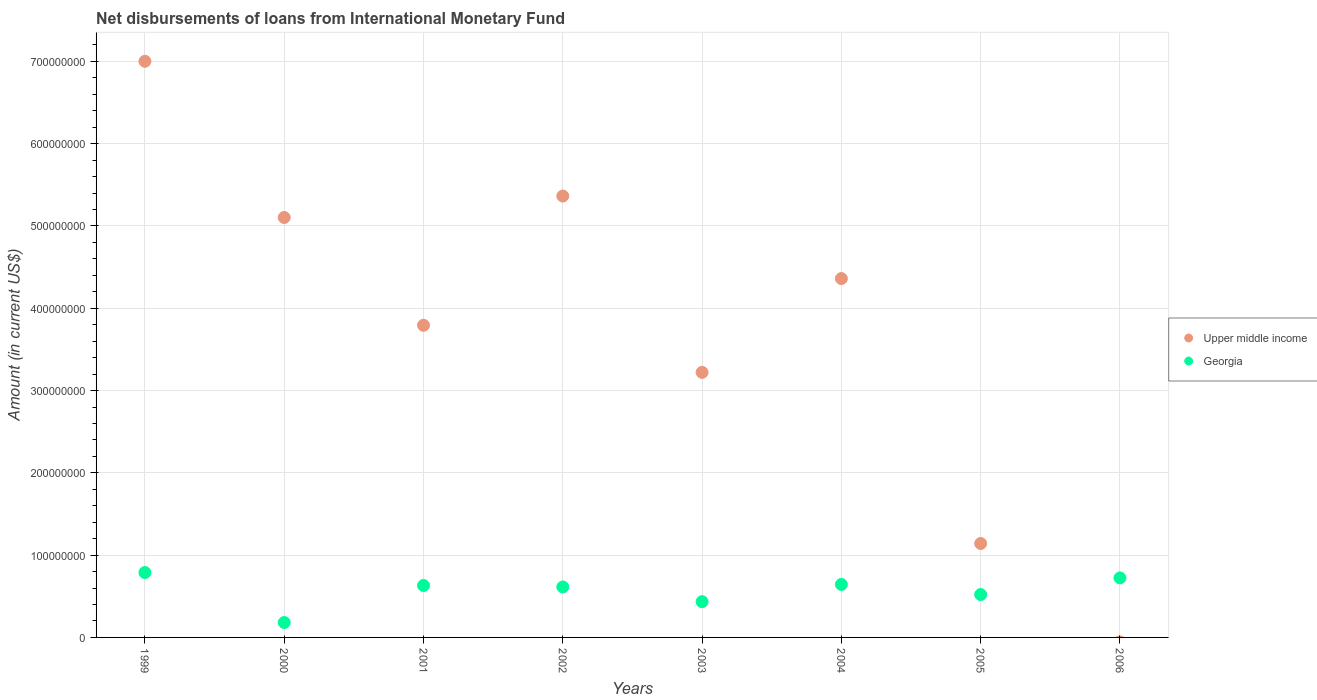Is the number of dotlines equal to the number of legend labels?
Offer a very short reply. No. What is the amount of loans disbursed in Upper middle income in 2005?
Make the answer very short. 1.14e+08. Across all years, what is the maximum amount of loans disbursed in Georgia?
Your answer should be compact. 7.88e+07. Across all years, what is the minimum amount of loans disbursed in Georgia?
Ensure brevity in your answer.  1.81e+07. What is the total amount of loans disbursed in Upper middle income in the graph?
Provide a succinct answer. 3.00e+09. What is the difference between the amount of loans disbursed in Georgia in 2001 and that in 2006?
Your answer should be compact. -9.24e+06. What is the difference between the amount of loans disbursed in Georgia in 2002 and the amount of loans disbursed in Upper middle income in 1999?
Make the answer very short. -6.39e+08. What is the average amount of loans disbursed in Upper middle income per year?
Provide a succinct answer. 3.75e+08. In the year 1999, what is the difference between the amount of loans disbursed in Upper middle income and amount of loans disbursed in Georgia?
Offer a terse response. 6.21e+08. In how many years, is the amount of loans disbursed in Upper middle income greater than 600000000 US$?
Provide a succinct answer. 1. What is the ratio of the amount of loans disbursed in Georgia in 1999 to that in 2003?
Your response must be concise. 1.81. Is the amount of loans disbursed in Upper middle income in 2000 less than that in 2004?
Provide a succinct answer. No. Is the difference between the amount of loans disbursed in Upper middle income in 1999 and 2002 greater than the difference between the amount of loans disbursed in Georgia in 1999 and 2002?
Keep it short and to the point. Yes. What is the difference between the highest and the second highest amount of loans disbursed in Georgia?
Your answer should be very brief. 6.50e+06. What is the difference between the highest and the lowest amount of loans disbursed in Upper middle income?
Offer a terse response. 7.00e+08. Does the amount of loans disbursed in Upper middle income monotonically increase over the years?
Provide a short and direct response. No. How many years are there in the graph?
Your response must be concise. 8. What is the difference between two consecutive major ticks on the Y-axis?
Provide a short and direct response. 1.00e+08. Are the values on the major ticks of Y-axis written in scientific E-notation?
Make the answer very short. No. Does the graph contain grids?
Offer a very short reply. Yes. Where does the legend appear in the graph?
Offer a terse response. Center right. How many legend labels are there?
Your response must be concise. 2. What is the title of the graph?
Provide a short and direct response. Net disbursements of loans from International Monetary Fund. What is the Amount (in current US$) of Upper middle income in 1999?
Offer a terse response. 7.00e+08. What is the Amount (in current US$) of Georgia in 1999?
Your response must be concise. 7.88e+07. What is the Amount (in current US$) of Upper middle income in 2000?
Provide a succinct answer. 5.10e+08. What is the Amount (in current US$) of Georgia in 2000?
Offer a terse response. 1.81e+07. What is the Amount (in current US$) in Upper middle income in 2001?
Provide a short and direct response. 3.79e+08. What is the Amount (in current US$) in Georgia in 2001?
Provide a short and direct response. 6.31e+07. What is the Amount (in current US$) of Upper middle income in 2002?
Offer a very short reply. 5.36e+08. What is the Amount (in current US$) in Georgia in 2002?
Offer a very short reply. 6.13e+07. What is the Amount (in current US$) in Upper middle income in 2003?
Your response must be concise. 3.22e+08. What is the Amount (in current US$) of Georgia in 2003?
Make the answer very short. 4.35e+07. What is the Amount (in current US$) of Upper middle income in 2004?
Provide a succinct answer. 4.36e+08. What is the Amount (in current US$) in Georgia in 2004?
Keep it short and to the point. 6.44e+07. What is the Amount (in current US$) in Upper middle income in 2005?
Offer a very short reply. 1.14e+08. What is the Amount (in current US$) of Georgia in 2005?
Keep it short and to the point. 5.21e+07. What is the Amount (in current US$) of Upper middle income in 2006?
Your answer should be compact. 0. What is the Amount (in current US$) in Georgia in 2006?
Your answer should be very brief. 7.23e+07. Across all years, what is the maximum Amount (in current US$) in Upper middle income?
Your answer should be compact. 7.00e+08. Across all years, what is the maximum Amount (in current US$) in Georgia?
Provide a succinct answer. 7.88e+07. Across all years, what is the minimum Amount (in current US$) of Georgia?
Give a very brief answer. 1.81e+07. What is the total Amount (in current US$) in Upper middle income in the graph?
Keep it short and to the point. 3.00e+09. What is the total Amount (in current US$) in Georgia in the graph?
Ensure brevity in your answer.  4.54e+08. What is the difference between the Amount (in current US$) of Upper middle income in 1999 and that in 2000?
Your answer should be compact. 1.90e+08. What is the difference between the Amount (in current US$) in Georgia in 1999 and that in 2000?
Provide a short and direct response. 6.07e+07. What is the difference between the Amount (in current US$) of Upper middle income in 1999 and that in 2001?
Your answer should be very brief. 3.21e+08. What is the difference between the Amount (in current US$) in Georgia in 1999 and that in 2001?
Your answer should be compact. 1.57e+07. What is the difference between the Amount (in current US$) of Upper middle income in 1999 and that in 2002?
Your answer should be compact. 1.64e+08. What is the difference between the Amount (in current US$) of Georgia in 1999 and that in 2002?
Offer a terse response. 1.75e+07. What is the difference between the Amount (in current US$) in Upper middle income in 1999 and that in 2003?
Ensure brevity in your answer.  3.78e+08. What is the difference between the Amount (in current US$) in Georgia in 1999 and that in 2003?
Your answer should be very brief. 3.54e+07. What is the difference between the Amount (in current US$) of Upper middle income in 1999 and that in 2004?
Provide a short and direct response. 2.64e+08. What is the difference between the Amount (in current US$) in Georgia in 1999 and that in 2004?
Ensure brevity in your answer.  1.45e+07. What is the difference between the Amount (in current US$) in Upper middle income in 1999 and that in 2005?
Your answer should be compact. 5.86e+08. What is the difference between the Amount (in current US$) in Georgia in 1999 and that in 2005?
Provide a short and direct response. 2.67e+07. What is the difference between the Amount (in current US$) of Georgia in 1999 and that in 2006?
Keep it short and to the point. 6.50e+06. What is the difference between the Amount (in current US$) of Upper middle income in 2000 and that in 2001?
Provide a short and direct response. 1.31e+08. What is the difference between the Amount (in current US$) of Georgia in 2000 and that in 2001?
Your response must be concise. -4.50e+07. What is the difference between the Amount (in current US$) of Upper middle income in 2000 and that in 2002?
Offer a terse response. -2.61e+07. What is the difference between the Amount (in current US$) of Georgia in 2000 and that in 2002?
Your answer should be very brief. -4.32e+07. What is the difference between the Amount (in current US$) in Upper middle income in 2000 and that in 2003?
Ensure brevity in your answer.  1.88e+08. What is the difference between the Amount (in current US$) in Georgia in 2000 and that in 2003?
Your response must be concise. -2.54e+07. What is the difference between the Amount (in current US$) in Upper middle income in 2000 and that in 2004?
Give a very brief answer. 7.42e+07. What is the difference between the Amount (in current US$) in Georgia in 2000 and that in 2004?
Provide a succinct answer. -4.63e+07. What is the difference between the Amount (in current US$) in Upper middle income in 2000 and that in 2005?
Your answer should be compact. 3.96e+08. What is the difference between the Amount (in current US$) of Georgia in 2000 and that in 2005?
Offer a terse response. -3.40e+07. What is the difference between the Amount (in current US$) of Georgia in 2000 and that in 2006?
Your answer should be compact. -5.42e+07. What is the difference between the Amount (in current US$) of Upper middle income in 2001 and that in 2002?
Provide a succinct answer. -1.57e+08. What is the difference between the Amount (in current US$) in Georgia in 2001 and that in 2002?
Your answer should be compact. 1.78e+06. What is the difference between the Amount (in current US$) in Upper middle income in 2001 and that in 2003?
Provide a succinct answer. 5.72e+07. What is the difference between the Amount (in current US$) of Georgia in 2001 and that in 2003?
Offer a terse response. 1.96e+07. What is the difference between the Amount (in current US$) of Upper middle income in 2001 and that in 2004?
Ensure brevity in your answer.  -5.68e+07. What is the difference between the Amount (in current US$) of Georgia in 2001 and that in 2004?
Ensure brevity in your answer.  -1.27e+06. What is the difference between the Amount (in current US$) of Upper middle income in 2001 and that in 2005?
Provide a short and direct response. 2.65e+08. What is the difference between the Amount (in current US$) in Georgia in 2001 and that in 2005?
Give a very brief answer. 1.10e+07. What is the difference between the Amount (in current US$) in Georgia in 2001 and that in 2006?
Make the answer very short. -9.24e+06. What is the difference between the Amount (in current US$) of Upper middle income in 2002 and that in 2003?
Give a very brief answer. 2.14e+08. What is the difference between the Amount (in current US$) in Georgia in 2002 and that in 2003?
Give a very brief answer. 1.79e+07. What is the difference between the Amount (in current US$) of Upper middle income in 2002 and that in 2004?
Offer a very short reply. 1.00e+08. What is the difference between the Amount (in current US$) in Georgia in 2002 and that in 2004?
Provide a short and direct response. -3.05e+06. What is the difference between the Amount (in current US$) in Upper middle income in 2002 and that in 2005?
Your answer should be very brief. 4.22e+08. What is the difference between the Amount (in current US$) of Georgia in 2002 and that in 2005?
Offer a terse response. 9.24e+06. What is the difference between the Amount (in current US$) of Georgia in 2002 and that in 2006?
Your answer should be compact. -1.10e+07. What is the difference between the Amount (in current US$) of Upper middle income in 2003 and that in 2004?
Ensure brevity in your answer.  -1.14e+08. What is the difference between the Amount (in current US$) of Georgia in 2003 and that in 2004?
Provide a succinct answer. -2.09e+07. What is the difference between the Amount (in current US$) in Upper middle income in 2003 and that in 2005?
Offer a very short reply. 2.08e+08. What is the difference between the Amount (in current US$) of Georgia in 2003 and that in 2005?
Provide a succinct answer. -8.63e+06. What is the difference between the Amount (in current US$) in Georgia in 2003 and that in 2006?
Ensure brevity in your answer.  -2.89e+07. What is the difference between the Amount (in current US$) in Upper middle income in 2004 and that in 2005?
Provide a short and direct response. 3.22e+08. What is the difference between the Amount (in current US$) of Georgia in 2004 and that in 2005?
Offer a very short reply. 1.23e+07. What is the difference between the Amount (in current US$) in Georgia in 2004 and that in 2006?
Your answer should be compact. -7.96e+06. What is the difference between the Amount (in current US$) in Georgia in 2005 and that in 2006?
Make the answer very short. -2.03e+07. What is the difference between the Amount (in current US$) of Upper middle income in 1999 and the Amount (in current US$) of Georgia in 2000?
Give a very brief answer. 6.82e+08. What is the difference between the Amount (in current US$) of Upper middle income in 1999 and the Amount (in current US$) of Georgia in 2001?
Your response must be concise. 6.37e+08. What is the difference between the Amount (in current US$) of Upper middle income in 1999 and the Amount (in current US$) of Georgia in 2002?
Offer a terse response. 6.39e+08. What is the difference between the Amount (in current US$) in Upper middle income in 1999 and the Amount (in current US$) in Georgia in 2003?
Give a very brief answer. 6.57e+08. What is the difference between the Amount (in current US$) of Upper middle income in 1999 and the Amount (in current US$) of Georgia in 2004?
Ensure brevity in your answer.  6.36e+08. What is the difference between the Amount (in current US$) in Upper middle income in 1999 and the Amount (in current US$) in Georgia in 2005?
Give a very brief answer. 6.48e+08. What is the difference between the Amount (in current US$) of Upper middle income in 1999 and the Amount (in current US$) of Georgia in 2006?
Your answer should be compact. 6.28e+08. What is the difference between the Amount (in current US$) of Upper middle income in 2000 and the Amount (in current US$) of Georgia in 2001?
Ensure brevity in your answer.  4.47e+08. What is the difference between the Amount (in current US$) in Upper middle income in 2000 and the Amount (in current US$) in Georgia in 2002?
Give a very brief answer. 4.49e+08. What is the difference between the Amount (in current US$) in Upper middle income in 2000 and the Amount (in current US$) in Georgia in 2003?
Ensure brevity in your answer.  4.67e+08. What is the difference between the Amount (in current US$) in Upper middle income in 2000 and the Amount (in current US$) in Georgia in 2004?
Keep it short and to the point. 4.46e+08. What is the difference between the Amount (in current US$) of Upper middle income in 2000 and the Amount (in current US$) of Georgia in 2005?
Ensure brevity in your answer.  4.58e+08. What is the difference between the Amount (in current US$) of Upper middle income in 2000 and the Amount (in current US$) of Georgia in 2006?
Keep it short and to the point. 4.38e+08. What is the difference between the Amount (in current US$) of Upper middle income in 2001 and the Amount (in current US$) of Georgia in 2002?
Ensure brevity in your answer.  3.18e+08. What is the difference between the Amount (in current US$) of Upper middle income in 2001 and the Amount (in current US$) of Georgia in 2003?
Offer a very short reply. 3.36e+08. What is the difference between the Amount (in current US$) of Upper middle income in 2001 and the Amount (in current US$) of Georgia in 2004?
Make the answer very short. 3.15e+08. What is the difference between the Amount (in current US$) in Upper middle income in 2001 and the Amount (in current US$) in Georgia in 2005?
Offer a very short reply. 3.27e+08. What is the difference between the Amount (in current US$) of Upper middle income in 2001 and the Amount (in current US$) of Georgia in 2006?
Your answer should be compact. 3.07e+08. What is the difference between the Amount (in current US$) in Upper middle income in 2002 and the Amount (in current US$) in Georgia in 2003?
Provide a short and direct response. 4.93e+08. What is the difference between the Amount (in current US$) of Upper middle income in 2002 and the Amount (in current US$) of Georgia in 2004?
Your response must be concise. 4.72e+08. What is the difference between the Amount (in current US$) in Upper middle income in 2002 and the Amount (in current US$) in Georgia in 2005?
Your answer should be very brief. 4.84e+08. What is the difference between the Amount (in current US$) of Upper middle income in 2002 and the Amount (in current US$) of Georgia in 2006?
Offer a very short reply. 4.64e+08. What is the difference between the Amount (in current US$) of Upper middle income in 2003 and the Amount (in current US$) of Georgia in 2004?
Offer a very short reply. 2.58e+08. What is the difference between the Amount (in current US$) of Upper middle income in 2003 and the Amount (in current US$) of Georgia in 2005?
Your answer should be compact. 2.70e+08. What is the difference between the Amount (in current US$) in Upper middle income in 2003 and the Amount (in current US$) in Georgia in 2006?
Offer a very short reply. 2.50e+08. What is the difference between the Amount (in current US$) of Upper middle income in 2004 and the Amount (in current US$) of Georgia in 2005?
Offer a terse response. 3.84e+08. What is the difference between the Amount (in current US$) of Upper middle income in 2004 and the Amount (in current US$) of Georgia in 2006?
Your answer should be compact. 3.64e+08. What is the difference between the Amount (in current US$) of Upper middle income in 2005 and the Amount (in current US$) of Georgia in 2006?
Offer a terse response. 4.18e+07. What is the average Amount (in current US$) in Upper middle income per year?
Provide a succinct answer. 3.75e+08. What is the average Amount (in current US$) of Georgia per year?
Keep it short and to the point. 5.67e+07. In the year 1999, what is the difference between the Amount (in current US$) in Upper middle income and Amount (in current US$) in Georgia?
Make the answer very short. 6.21e+08. In the year 2000, what is the difference between the Amount (in current US$) of Upper middle income and Amount (in current US$) of Georgia?
Offer a very short reply. 4.92e+08. In the year 2001, what is the difference between the Amount (in current US$) in Upper middle income and Amount (in current US$) in Georgia?
Offer a terse response. 3.16e+08. In the year 2002, what is the difference between the Amount (in current US$) in Upper middle income and Amount (in current US$) in Georgia?
Offer a terse response. 4.75e+08. In the year 2003, what is the difference between the Amount (in current US$) in Upper middle income and Amount (in current US$) in Georgia?
Keep it short and to the point. 2.79e+08. In the year 2004, what is the difference between the Amount (in current US$) in Upper middle income and Amount (in current US$) in Georgia?
Give a very brief answer. 3.72e+08. In the year 2005, what is the difference between the Amount (in current US$) of Upper middle income and Amount (in current US$) of Georgia?
Offer a terse response. 6.21e+07. What is the ratio of the Amount (in current US$) of Upper middle income in 1999 to that in 2000?
Your answer should be compact. 1.37. What is the ratio of the Amount (in current US$) of Georgia in 1999 to that in 2000?
Keep it short and to the point. 4.36. What is the ratio of the Amount (in current US$) in Upper middle income in 1999 to that in 2001?
Offer a terse response. 1.85. What is the ratio of the Amount (in current US$) in Georgia in 1999 to that in 2001?
Ensure brevity in your answer.  1.25. What is the ratio of the Amount (in current US$) of Upper middle income in 1999 to that in 2002?
Your response must be concise. 1.31. What is the ratio of the Amount (in current US$) in Georgia in 1999 to that in 2002?
Ensure brevity in your answer.  1.29. What is the ratio of the Amount (in current US$) of Upper middle income in 1999 to that in 2003?
Ensure brevity in your answer.  2.17. What is the ratio of the Amount (in current US$) in Georgia in 1999 to that in 2003?
Provide a succinct answer. 1.81. What is the ratio of the Amount (in current US$) in Upper middle income in 1999 to that in 2004?
Offer a terse response. 1.61. What is the ratio of the Amount (in current US$) of Georgia in 1999 to that in 2004?
Give a very brief answer. 1.22. What is the ratio of the Amount (in current US$) in Upper middle income in 1999 to that in 2005?
Make the answer very short. 6.13. What is the ratio of the Amount (in current US$) of Georgia in 1999 to that in 2005?
Provide a short and direct response. 1.51. What is the ratio of the Amount (in current US$) of Georgia in 1999 to that in 2006?
Your answer should be compact. 1.09. What is the ratio of the Amount (in current US$) in Upper middle income in 2000 to that in 2001?
Offer a very short reply. 1.35. What is the ratio of the Amount (in current US$) in Georgia in 2000 to that in 2001?
Provide a short and direct response. 0.29. What is the ratio of the Amount (in current US$) in Upper middle income in 2000 to that in 2002?
Make the answer very short. 0.95. What is the ratio of the Amount (in current US$) in Georgia in 2000 to that in 2002?
Your answer should be very brief. 0.3. What is the ratio of the Amount (in current US$) of Upper middle income in 2000 to that in 2003?
Your answer should be compact. 1.58. What is the ratio of the Amount (in current US$) of Georgia in 2000 to that in 2003?
Offer a very short reply. 0.42. What is the ratio of the Amount (in current US$) in Upper middle income in 2000 to that in 2004?
Your answer should be very brief. 1.17. What is the ratio of the Amount (in current US$) in Georgia in 2000 to that in 2004?
Your answer should be compact. 0.28. What is the ratio of the Amount (in current US$) of Upper middle income in 2000 to that in 2005?
Your answer should be very brief. 4.47. What is the ratio of the Amount (in current US$) of Georgia in 2000 to that in 2005?
Your answer should be very brief. 0.35. What is the ratio of the Amount (in current US$) in Georgia in 2000 to that in 2006?
Provide a succinct answer. 0.25. What is the ratio of the Amount (in current US$) of Upper middle income in 2001 to that in 2002?
Your response must be concise. 0.71. What is the ratio of the Amount (in current US$) of Georgia in 2001 to that in 2002?
Your answer should be very brief. 1.03. What is the ratio of the Amount (in current US$) in Upper middle income in 2001 to that in 2003?
Provide a succinct answer. 1.18. What is the ratio of the Amount (in current US$) of Georgia in 2001 to that in 2003?
Your answer should be very brief. 1.45. What is the ratio of the Amount (in current US$) in Upper middle income in 2001 to that in 2004?
Provide a short and direct response. 0.87. What is the ratio of the Amount (in current US$) in Georgia in 2001 to that in 2004?
Give a very brief answer. 0.98. What is the ratio of the Amount (in current US$) in Upper middle income in 2001 to that in 2005?
Offer a terse response. 3.32. What is the ratio of the Amount (in current US$) in Georgia in 2001 to that in 2005?
Offer a terse response. 1.21. What is the ratio of the Amount (in current US$) in Georgia in 2001 to that in 2006?
Make the answer very short. 0.87. What is the ratio of the Amount (in current US$) of Upper middle income in 2002 to that in 2003?
Keep it short and to the point. 1.67. What is the ratio of the Amount (in current US$) in Georgia in 2002 to that in 2003?
Your response must be concise. 1.41. What is the ratio of the Amount (in current US$) of Upper middle income in 2002 to that in 2004?
Your answer should be very brief. 1.23. What is the ratio of the Amount (in current US$) of Georgia in 2002 to that in 2004?
Provide a short and direct response. 0.95. What is the ratio of the Amount (in current US$) of Upper middle income in 2002 to that in 2005?
Your answer should be very brief. 4.7. What is the ratio of the Amount (in current US$) in Georgia in 2002 to that in 2005?
Your answer should be compact. 1.18. What is the ratio of the Amount (in current US$) of Georgia in 2002 to that in 2006?
Your answer should be compact. 0.85. What is the ratio of the Amount (in current US$) of Upper middle income in 2003 to that in 2004?
Provide a succinct answer. 0.74. What is the ratio of the Amount (in current US$) of Georgia in 2003 to that in 2004?
Provide a short and direct response. 0.68. What is the ratio of the Amount (in current US$) in Upper middle income in 2003 to that in 2005?
Your answer should be compact. 2.82. What is the ratio of the Amount (in current US$) in Georgia in 2003 to that in 2005?
Offer a very short reply. 0.83. What is the ratio of the Amount (in current US$) in Georgia in 2003 to that in 2006?
Your response must be concise. 0.6. What is the ratio of the Amount (in current US$) in Upper middle income in 2004 to that in 2005?
Your answer should be compact. 3.82. What is the ratio of the Amount (in current US$) of Georgia in 2004 to that in 2005?
Provide a short and direct response. 1.24. What is the ratio of the Amount (in current US$) in Georgia in 2004 to that in 2006?
Offer a very short reply. 0.89. What is the ratio of the Amount (in current US$) of Georgia in 2005 to that in 2006?
Keep it short and to the point. 0.72. What is the difference between the highest and the second highest Amount (in current US$) in Upper middle income?
Your answer should be compact. 1.64e+08. What is the difference between the highest and the second highest Amount (in current US$) in Georgia?
Offer a terse response. 6.50e+06. What is the difference between the highest and the lowest Amount (in current US$) of Upper middle income?
Give a very brief answer. 7.00e+08. What is the difference between the highest and the lowest Amount (in current US$) in Georgia?
Provide a succinct answer. 6.07e+07. 